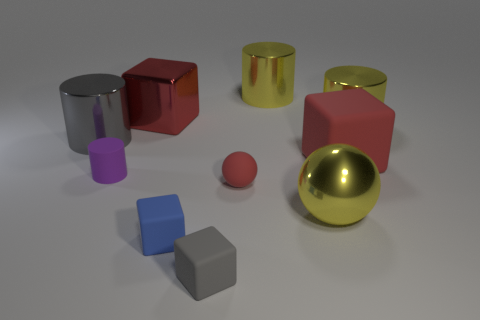Subtract all yellow cylinders. How many red blocks are left? 2 Subtract all rubber cubes. How many cubes are left? 1 Subtract 1 cubes. How many cubes are left? 3 Subtract all purple cylinders. How many cylinders are left? 3 Subtract all cylinders. How many objects are left? 6 Add 2 metal things. How many metal things exist? 7 Subtract 0 red cylinders. How many objects are left? 10 Subtract all purple cylinders. Subtract all cyan blocks. How many cylinders are left? 3 Subtract all big yellow metallic balls. Subtract all small blue rubber things. How many objects are left? 8 Add 8 big rubber cubes. How many big rubber cubes are left? 9 